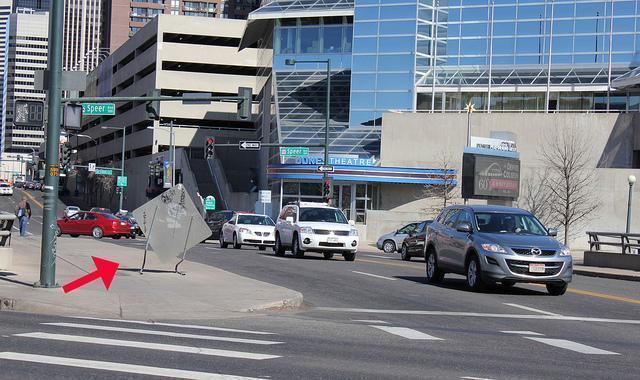What boulevard is the Jones Theater on?
Indicate the correct response and explain using: 'Answer: answer
Rationale: rationale.'
Options: Speer, 12th, curtis, spire. Answer: speer.
Rationale: The street sign has the name of the street that this theater is on. 